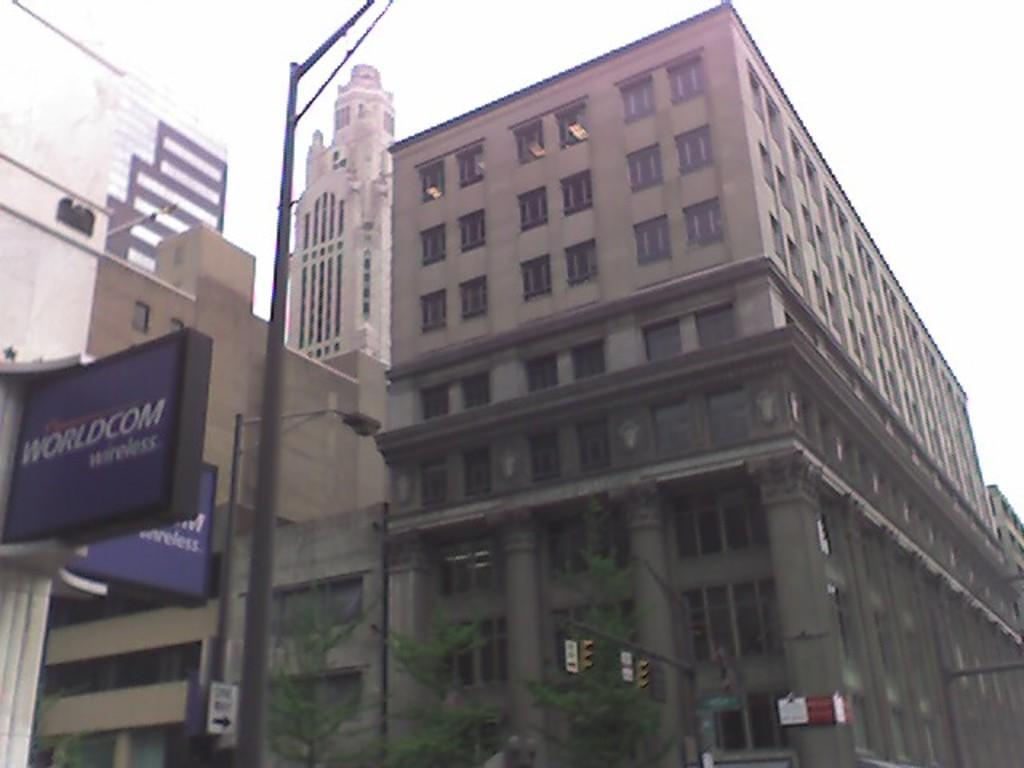What type of structures can be seen in the image? There are buildings in the image. What type of lighting is present in the image? There is a street lamp in the image. What type of decorations are present in the image? There are banners in the image. What type of vegetation is present in the image? There are plants in the image. What is visible in the background of the image? The sky is visible in the image. What type of egg is being used as a basketball in the image? There is no egg or basketball present in the image. What is the condition of the plants in the image? The provided facts do not mention the condition of the plants, only that they are present in the image. 